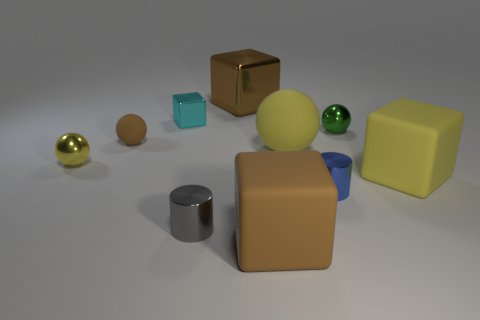Subtract 1 spheres. How many spheres are left? 3 Subtract all cylinders. How many objects are left? 8 Subtract all tiny gray metallic cylinders. Subtract all big brown rubber things. How many objects are left? 8 Add 6 small gray objects. How many small gray objects are left? 7 Add 1 matte things. How many matte things exist? 5 Subtract 1 brown cubes. How many objects are left? 9 